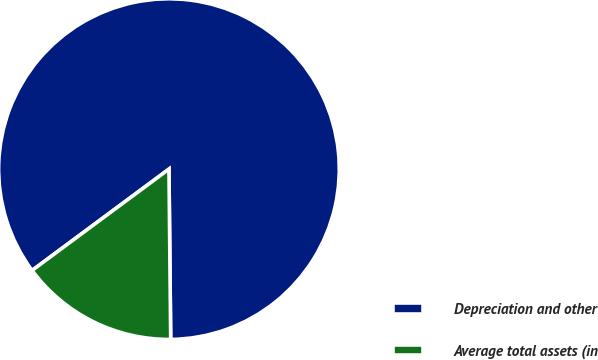<chart> <loc_0><loc_0><loc_500><loc_500><pie_chart><fcel>Depreciation and other<fcel>Average total assets (in<nl><fcel>84.98%<fcel>15.02%<nl></chart> 